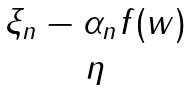Convert formula to latex. <formula><loc_0><loc_0><loc_500><loc_500>\begin{matrix} \xi _ { n } - \alpha _ { n } f ( w ) \\ \eta \end{matrix}</formula> 